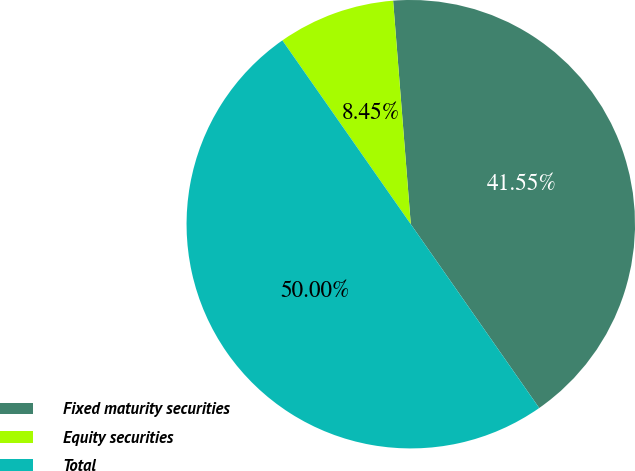Convert chart. <chart><loc_0><loc_0><loc_500><loc_500><pie_chart><fcel>Fixed maturity securities<fcel>Equity securities<fcel>Total<nl><fcel>41.55%<fcel>8.45%<fcel>50.0%<nl></chart> 